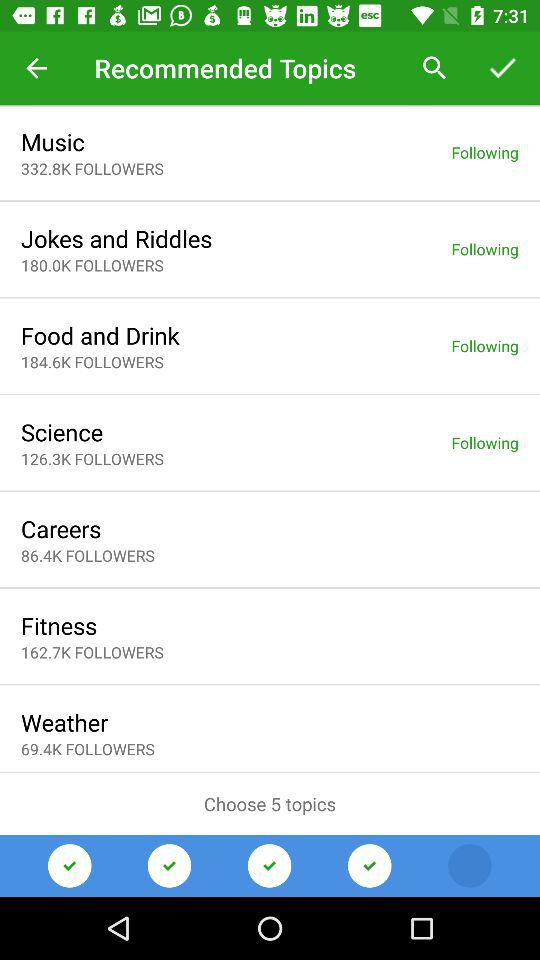How many followers does "Careers" have? "Careers" has 86.4K followers. 